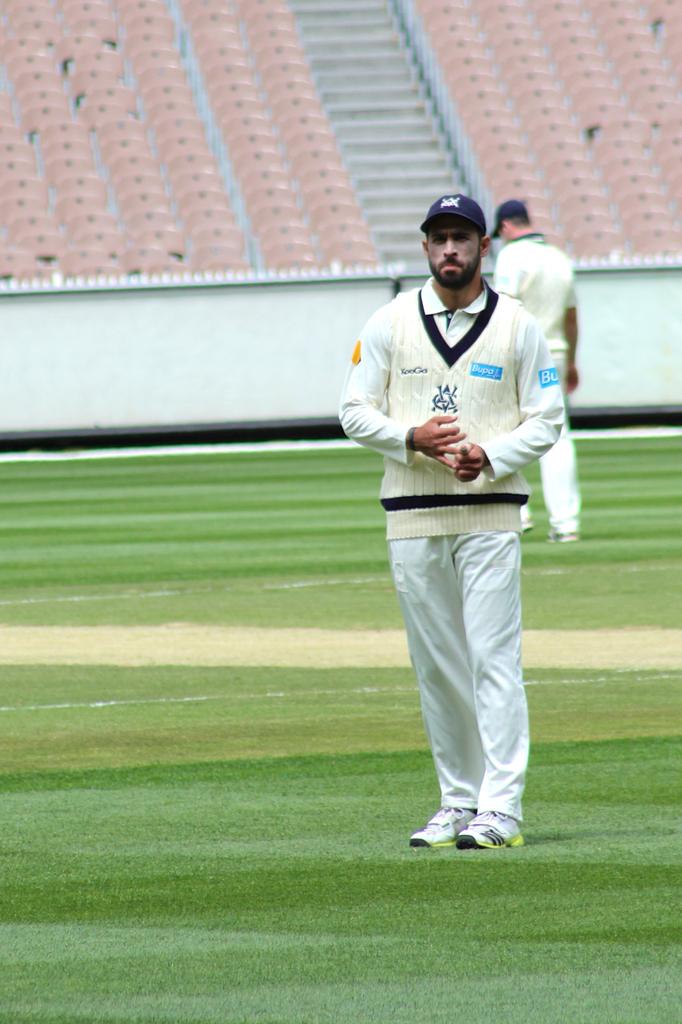What are the letters in the monogram in the middle of the sweater?
Your answer should be very brief. Unanswerable. How many players are on the field?
Provide a short and direct response. 2. 